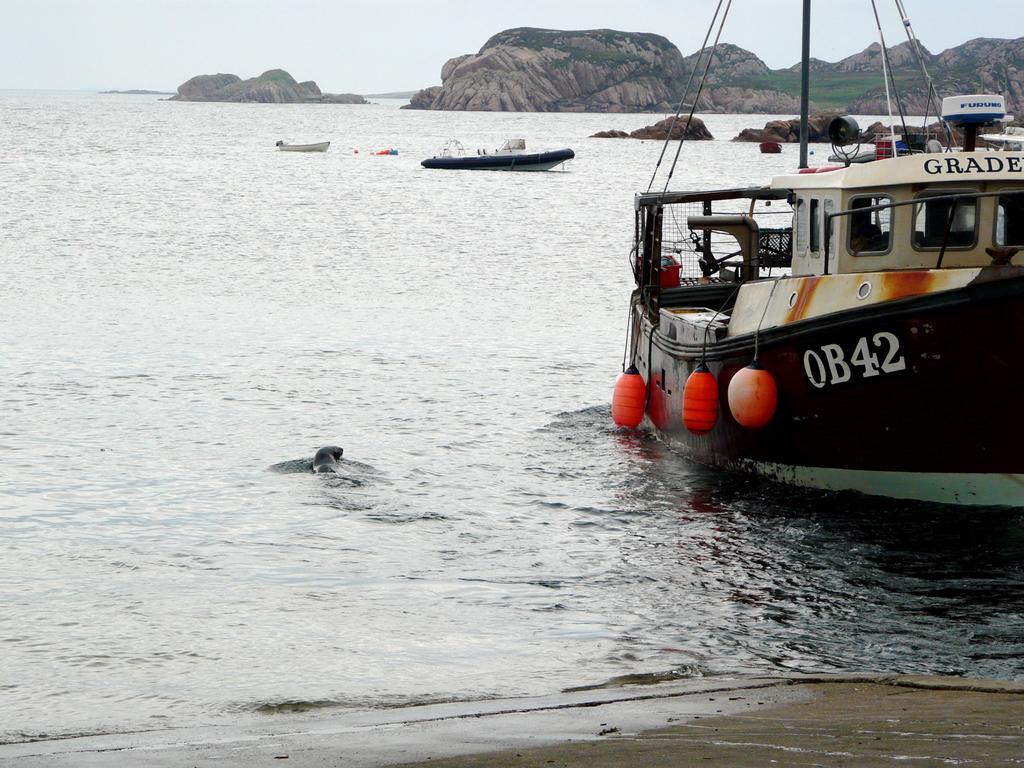In one or two sentences, can you explain what this image depicts? In this image there are boats. There is a sea. In the background there are hills and sky. 